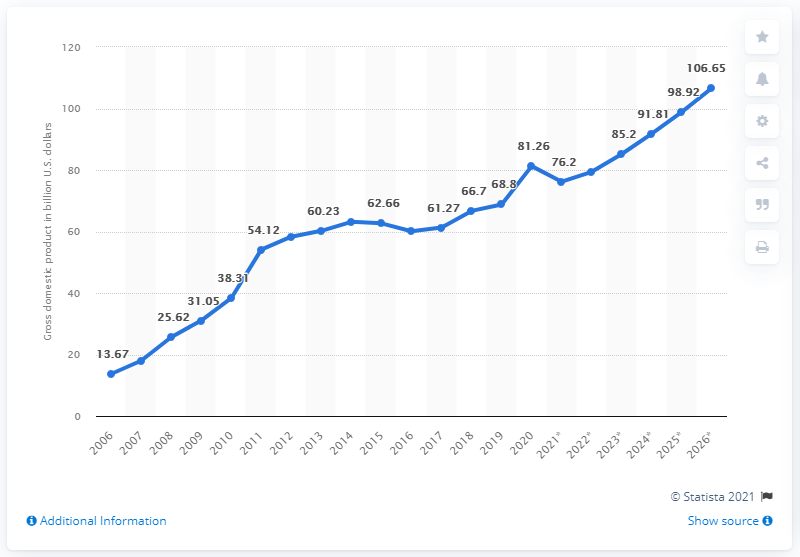Point out several critical features in this image. In 2020, Myanmar's gross domestic product (GDP) was estimated to be approximately 81.26 billion dollars. 